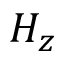<formula> <loc_0><loc_0><loc_500><loc_500>H _ { z }</formula> 